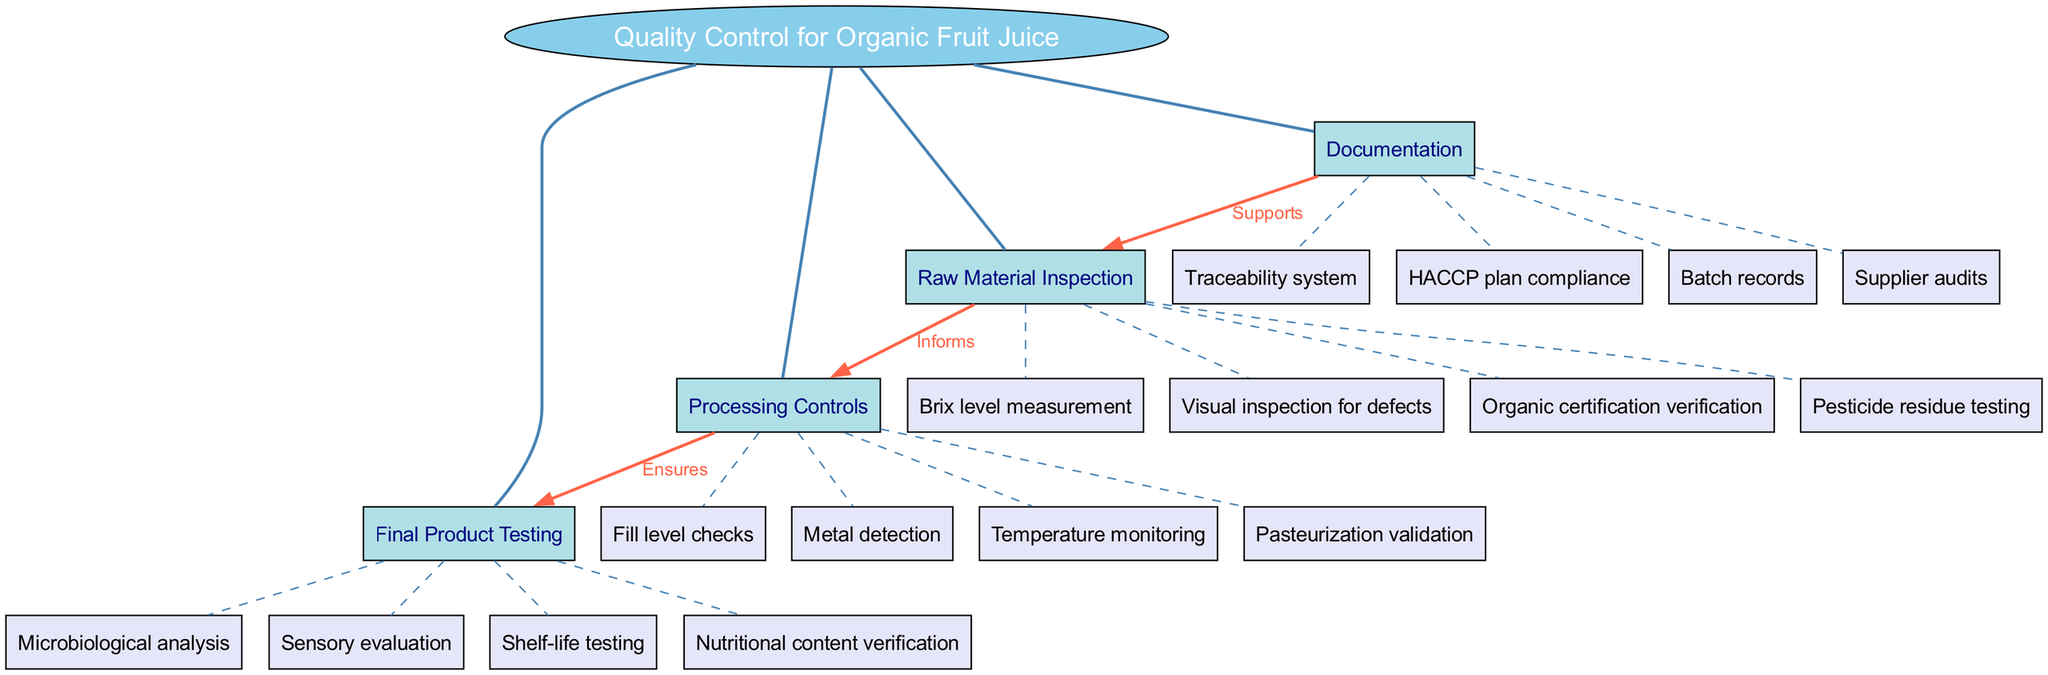What is the central concept of the diagram? The central concept is explicitly labeled as "Quality Control for Organic Fruit Juice" in the diagram.
Answer: Quality Control for Organic Fruit Juice How many main branches are there in the diagram? The diagram contains four main branches: Raw Material Inspection, Processing Controls, Final Product Testing, and Documentation. Counting these branches gives a total of four.
Answer: Four Which sub-branch falls under Raw Material Inspection? The diagram shows multiple sub-branches under Raw Material Inspection, one of which is "Pesticide residue testing." This is directly connected to the main branch.
Answer: Pesticide residue testing What relationship does "Processing Controls" have with "Final Product Testing"? The diagram indicates that "Processing Controls" ensures "Final Product Testing," as denoted by a directed edge labeled "Ensures" between the two nodes.
Answer: Ensures Which branch supports "Raw Material Inspection"? According to the diagram, "Documentation" supports "Raw Material Inspection," as indicated by a directed edge labeled "Supports" leading from "Documentation" to "Raw Material Inspection."
Answer: Documentation What type of analysis is part of Final Product Testing? From the sub-branches under Final Product Testing, "Microbiological analysis" is one specific type of analysis that is listed.
Answer: Microbiological analysis How does "Raw Material Inspection" inform "Processing Controls"? The diagram specifies a directed edge labeled "Informs" connecting "Raw Material Inspection" to "Processing Controls," indicating that findings from the inspection process inform the controls applied during processing.
Answer: Informs What is the label on the edge connecting Documentation to Raw Material Inspection? The edge connecting "Documentation" to "Raw Material Inspection" is labeled "Supports," indicating the relationship defined in the diagram.
Answer: Supports Which sub-branch represents "Nutritional content verification"? The sub-branch "Nutritional content verification" is specifically listed under the main branch "Final Product Testing" in the diagram.
Answer: Nutritional content verification 